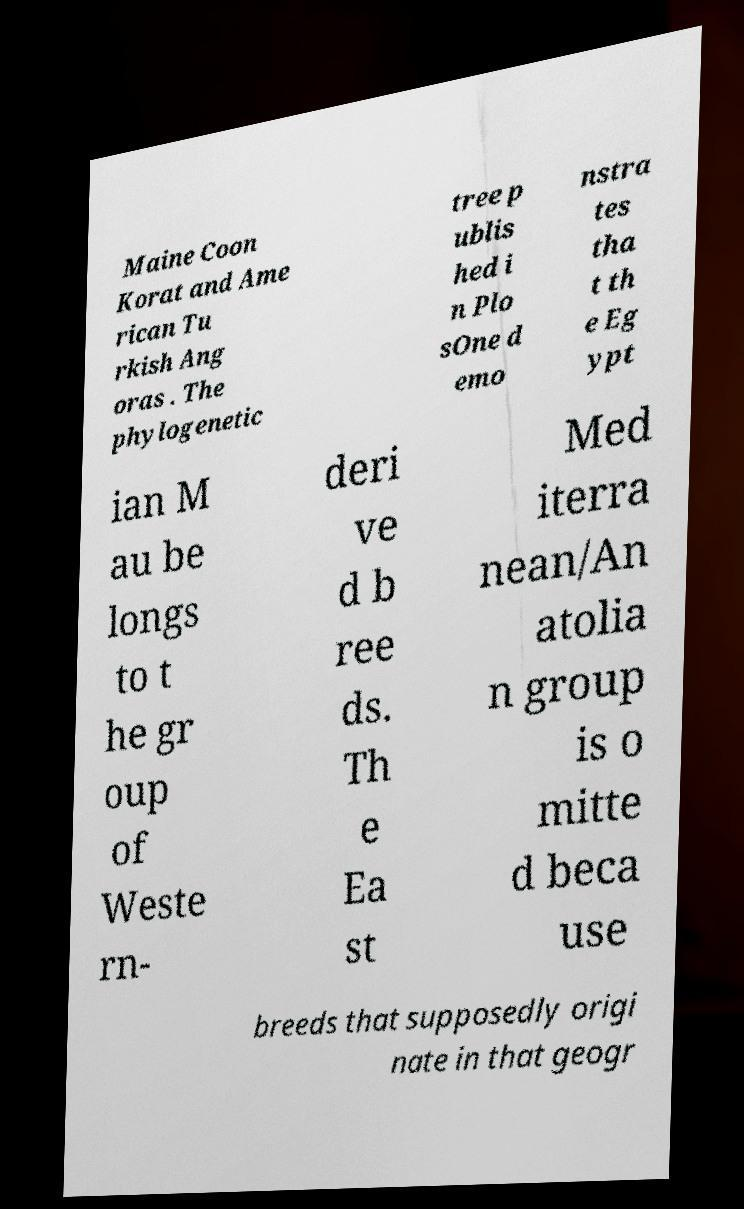Could you extract and type out the text from this image? Maine Coon Korat and Ame rican Tu rkish Ang oras . The phylogenetic tree p ublis hed i n Plo sOne d emo nstra tes tha t th e Eg ypt ian M au be longs to t he gr oup of Weste rn- deri ve d b ree ds. Th e Ea st Med iterra nean/An atolia n group is o mitte d beca use breeds that supposedly origi nate in that geogr 